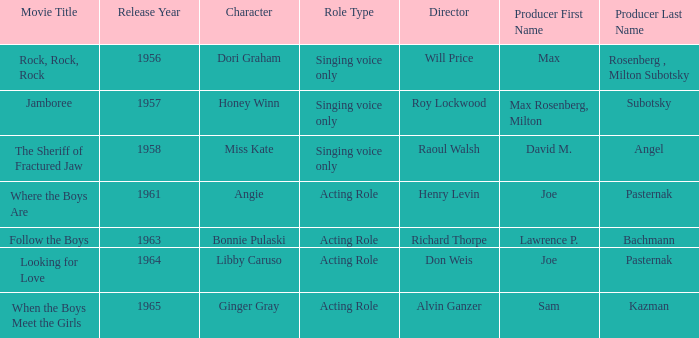What year was Jamboree made? 1957.0. 